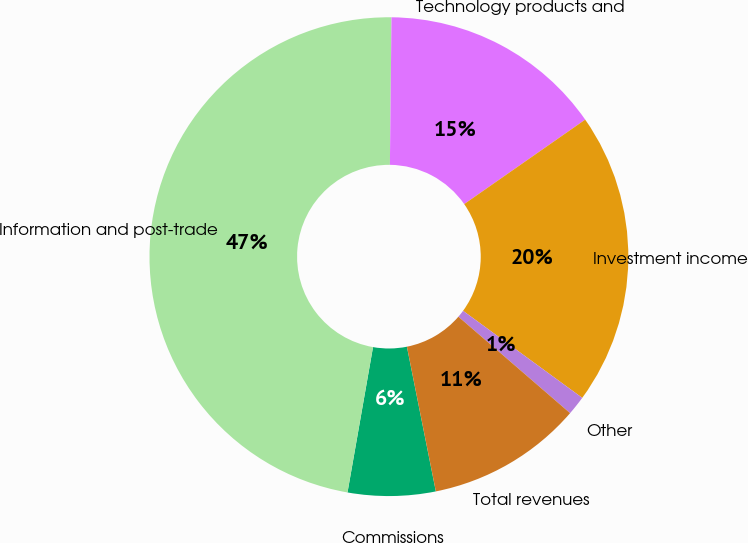Convert chart to OTSL. <chart><loc_0><loc_0><loc_500><loc_500><pie_chart><fcel>Commissions<fcel>Information and post-trade<fcel>Technology products and<fcel>Investment income<fcel>Other<fcel>Total revenues<nl><fcel>5.91%<fcel>47.41%<fcel>15.13%<fcel>19.74%<fcel>1.3%<fcel>10.52%<nl></chart> 